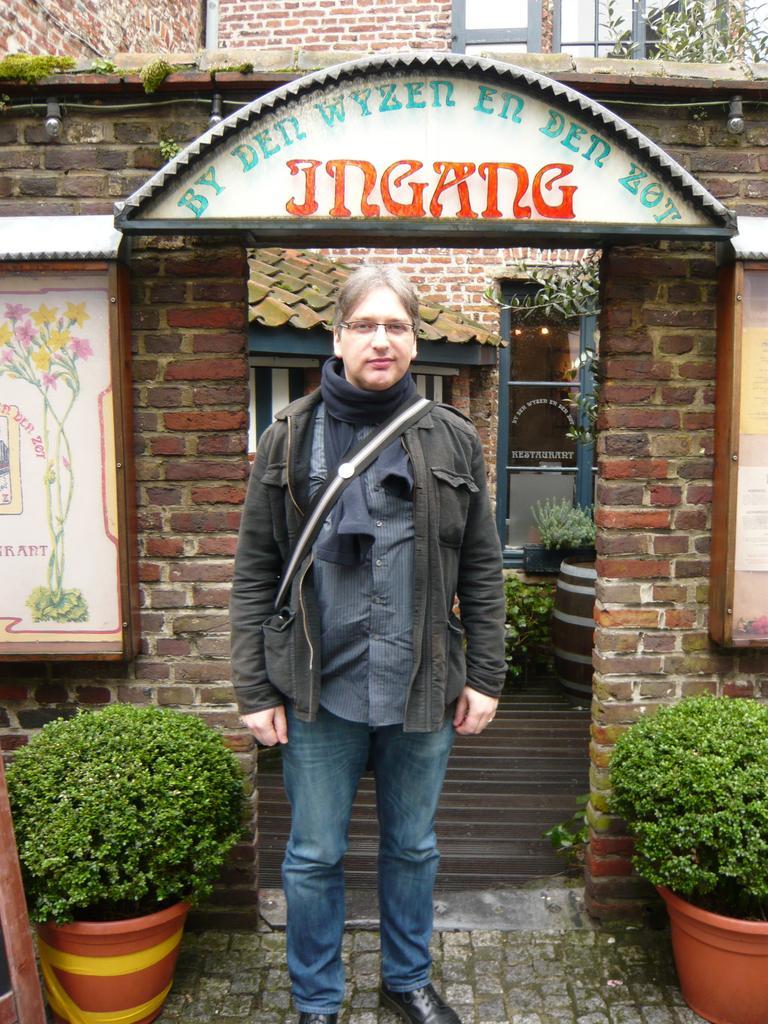Please provide a concise description of this image. In the image there is a man standing in the foreground, there are two plants on the either side of the man and behind him there are two frames, an arch and inside the arch there are windows, roof and a door. 